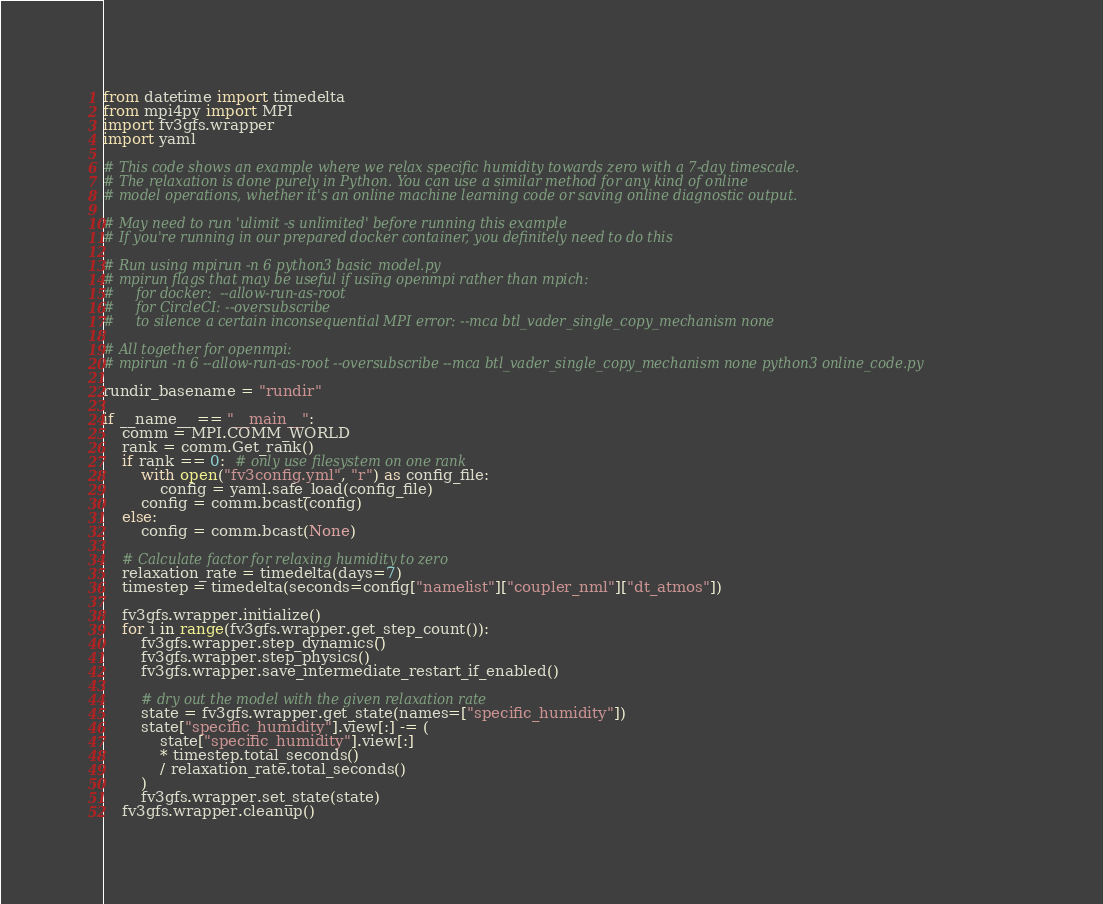<code> <loc_0><loc_0><loc_500><loc_500><_Python_>from datetime import timedelta
from mpi4py import MPI
import fv3gfs.wrapper
import yaml

# This code shows an example where we relax specific humidity towards zero with a 7-day timescale.
# The relaxation is done purely in Python. You can use a similar method for any kind of online
# model operations, whether it's an online machine learning code or saving online diagnostic output.

# May need to run 'ulimit -s unlimited' before running this example
# If you're running in our prepared docker container, you definitely need to do this

# Run using mpirun -n 6 python3 basic_model.py
# mpirun flags that may be useful if using openmpi rather than mpich:
#     for docker:  --allow-run-as-root
#     for CircleCI: --oversubscribe
#     to silence a certain inconsequential MPI error: --mca btl_vader_single_copy_mechanism none

# All together for openmpi:
# mpirun -n 6 --allow-run-as-root --oversubscribe --mca btl_vader_single_copy_mechanism none python3 online_code.py

rundir_basename = "rundir"

if __name__ == "__main__":
    comm = MPI.COMM_WORLD
    rank = comm.Get_rank()
    if rank == 0:  # only use filesystem on one rank
        with open("fv3config.yml", "r") as config_file:
            config = yaml.safe_load(config_file)
        config = comm.bcast(config)
    else:
        config = comm.bcast(None)

    # Calculate factor for relaxing humidity to zero
    relaxation_rate = timedelta(days=7)
    timestep = timedelta(seconds=config["namelist"]["coupler_nml"]["dt_atmos"])

    fv3gfs.wrapper.initialize()
    for i in range(fv3gfs.wrapper.get_step_count()):
        fv3gfs.wrapper.step_dynamics()
        fv3gfs.wrapper.step_physics()
        fv3gfs.wrapper.save_intermediate_restart_if_enabled()

        # dry out the model with the given relaxation rate
        state = fv3gfs.wrapper.get_state(names=["specific_humidity"])
        state["specific_humidity"].view[:] -= (
            state["specific_humidity"].view[:]
            * timestep.total_seconds()
            / relaxation_rate.total_seconds()
        )
        fv3gfs.wrapper.set_state(state)
    fv3gfs.wrapper.cleanup()
</code> 